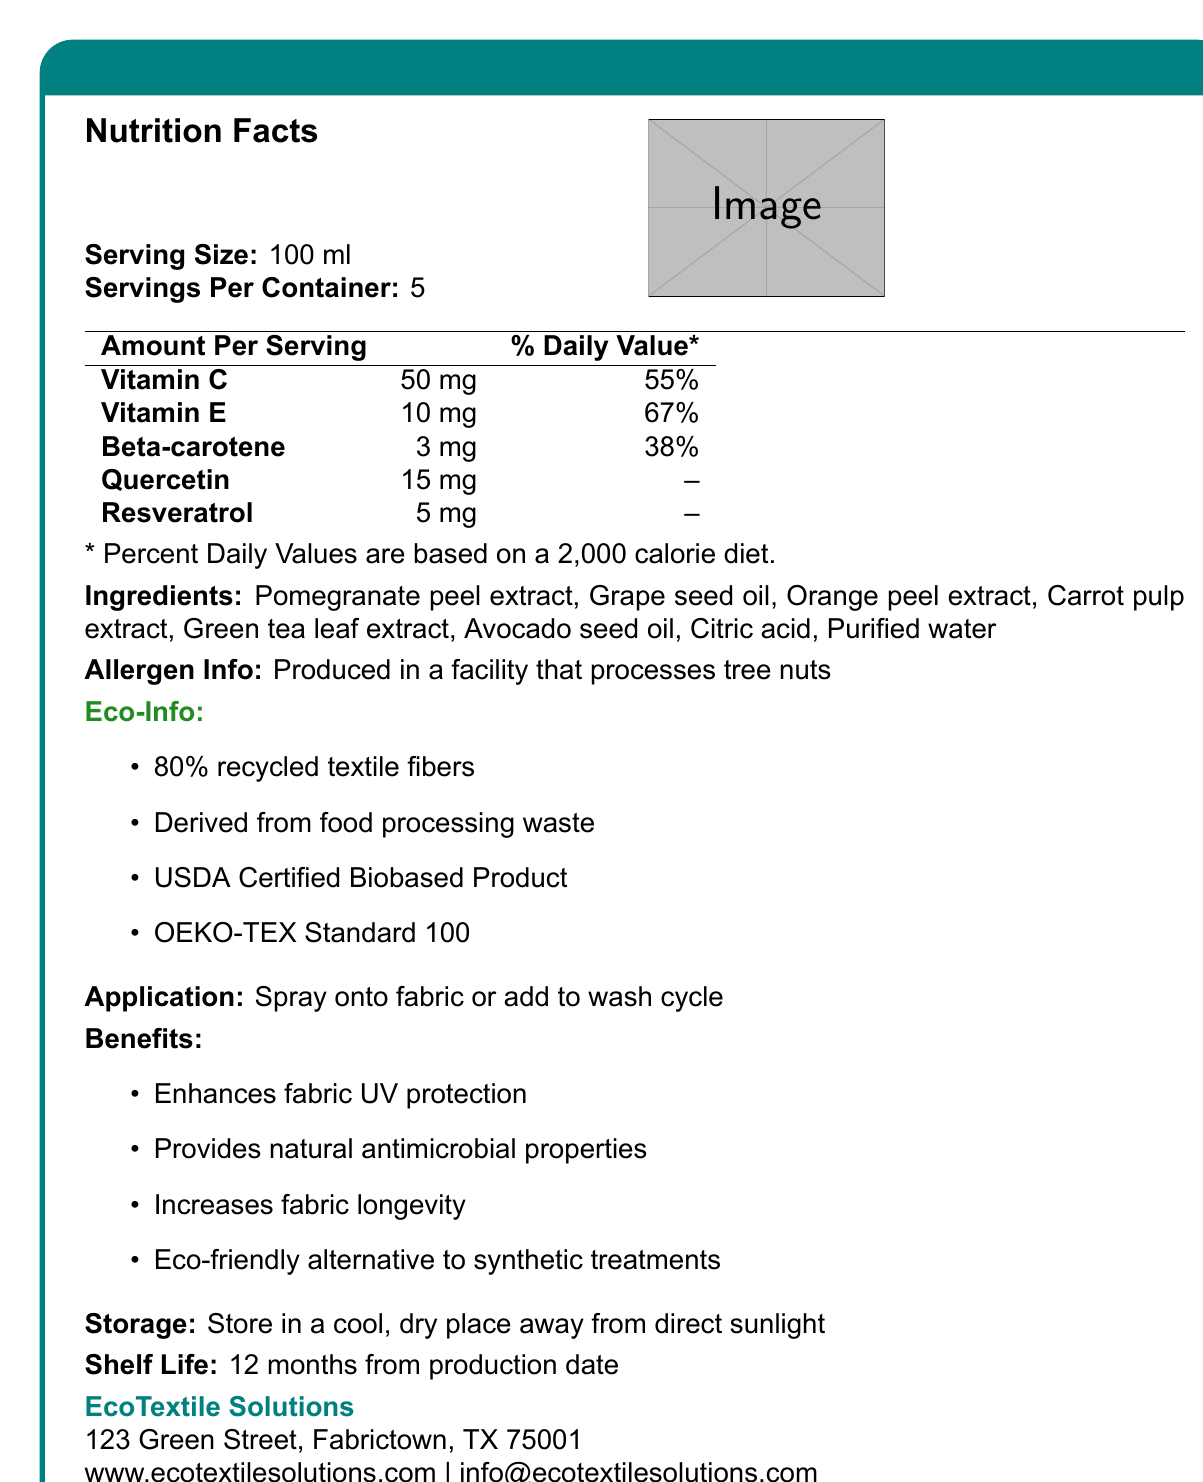what is the serving size of the EcoFabric Antioxidant Treatment? The document specifies that the serving size is 100 ml.
Answer: 100 ml how many servings per container does the EcoFabric Antioxidant Treatment have? The document states that there are 5 servings per container.
Answer: 5 which vitamins are listed in the EcoFabric Antioxidant Treatment? The document lists Vitamin C and Vitamin E among the nutrients.
Answer: Vitamin C, Vitamin E what is the percentage of daily value for Vitamin E? According to the nutrient information table, Vitamin E has a daily value of 67%.
Answer: 67% what is one of the major benefits of the EcoFabric Antioxidant Treatment? The document lists several benefits, with one of them being enhanced fabric UV protection.
Answer: Enhances fabric UV protection what is the allergen information provided for the EcoFabric Antioxidant Treatment? The document indicates that the product is produced in a facility that processes tree nuts.
Answer: Produced in a facility that processes tree nuts what are the main ingredients in the EcoFabric Antioxidant Treatment? A. Apple extract, Olive oil, Lemon peel extract B. Pomegranate peel extract, Grape seed oil, Orange peel extract C. Green tea leaf extract, Lemon peel extract, Orange pulp extract The listed ingredients in the document include Pomegranate peel extract, Grape seed oil, and Orange peel extract.
Answer: B. Pomegranate peel extract, Grape seed oil, Orange peel extract which certification does the EcoFabric Antioxidant Treatment have? A. USDA Certified Biobased Product B. Fair Trade Certified C. Global Organic Textile Standard (GOTS) The document shows that the product has the USDA Certified Biobased Product certification.
Answer: A. USDA Certified Biobased Product is the EcoFabric Antioxidant Treatment eco-friendly? The document describes the product as an eco-friendly alternative to synthetic treatments and lists several eco-friendly certifications and characteristics.
Answer: Yes summarize the main purpose of the EcoFabric Antioxidant Treatment. This summary captures the core aspects of the product, including its purpose, benefits, ingredients, and eco-friendly nature as described in the document.
Answer: The EcoFabric Antioxidant Treatment is a recycled textile treatment derived from food waste aimed at providing natural antioxidants to fabrics, enhancing UV protection, and offering antimicrobial properties while being an eco-friendly alternative to synthetic treatments. what is the percentage daily value of Quercetin? The document does not provide a daily value percentage for Quercetin, so this information cannot be determined.
Answer: Not enough information 